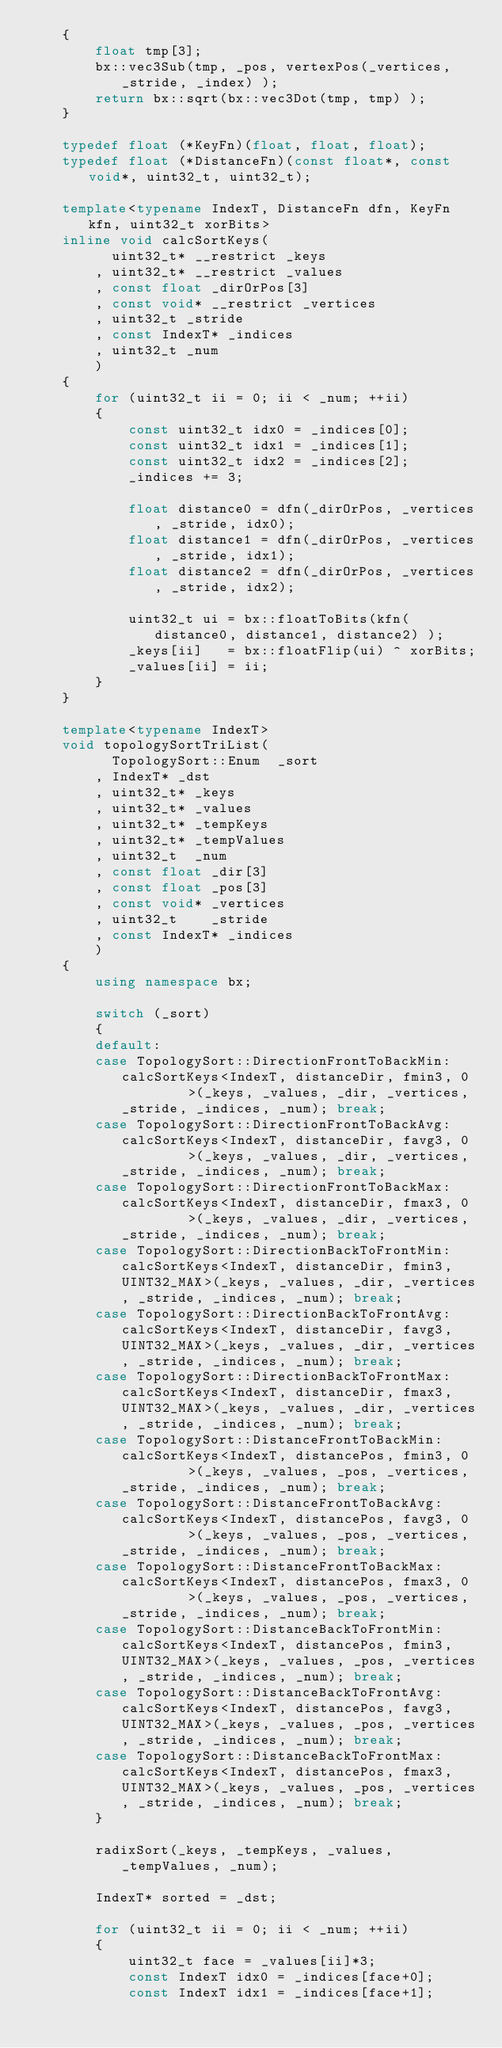<code> <loc_0><loc_0><loc_500><loc_500><_C++_>	{
		float tmp[3];
		bx::vec3Sub(tmp, _pos, vertexPos(_vertices, _stride, _index) );
		return bx::sqrt(bx::vec3Dot(tmp, tmp) );
	}

	typedef float (*KeyFn)(float, float, float);
	typedef float (*DistanceFn)(const float*, const void*, uint32_t, uint32_t);

	template<typename IndexT, DistanceFn dfn, KeyFn kfn, uint32_t xorBits>
	inline void calcSortKeys(
		  uint32_t* __restrict _keys
		, uint32_t* __restrict _values
		, const float _dirOrPos[3]
		, const void* __restrict _vertices
		, uint32_t _stride
		, const IndexT* _indices
		, uint32_t _num
		)
	{
		for (uint32_t ii = 0; ii < _num; ++ii)
		{
			const uint32_t idx0 = _indices[0];
			const uint32_t idx1 = _indices[1];
			const uint32_t idx2 = _indices[2];
			_indices += 3;

			float distance0 = dfn(_dirOrPos, _vertices, _stride, idx0);
			float distance1 = dfn(_dirOrPos, _vertices, _stride, idx1);
			float distance2 = dfn(_dirOrPos, _vertices, _stride, idx2);

			uint32_t ui = bx::floatToBits(kfn(distance0, distance1, distance2) );
			_keys[ii]   = bx::floatFlip(ui) ^ xorBits;
			_values[ii] = ii;
		}
	}

	template<typename IndexT>
	void topologySortTriList(
		  TopologySort::Enum  _sort
		, IndexT* _dst
		, uint32_t* _keys
		, uint32_t* _values
		, uint32_t* _tempKeys
		, uint32_t* _tempValues
		, uint32_t  _num
		, const float _dir[3]
		, const float _pos[3]
		, const void* _vertices
		, uint32_t    _stride
		, const IndexT* _indices
		)
	{
		using namespace bx;

		switch (_sort)
		{
		default:
		case TopologySort::DirectionFrontToBackMin: calcSortKeys<IndexT, distanceDir, fmin3, 0         >(_keys, _values, _dir, _vertices, _stride, _indices, _num); break;
		case TopologySort::DirectionFrontToBackAvg: calcSortKeys<IndexT, distanceDir, favg3, 0         >(_keys, _values, _dir, _vertices, _stride, _indices, _num); break;
		case TopologySort::DirectionFrontToBackMax: calcSortKeys<IndexT, distanceDir, fmax3, 0         >(_keys, _values, _dir, _vertices, _stride, _indices, _num); break;
		case TopologySort::DirectionBackToFrontMin: calcSortKeys<IndexT, distanceDir, fmin3, UINT32_MAX>(_keys, _values, _dir, _vertices, _stride, _indices, _num); break;
		case TopologySort::DirectionBackToFrontAvg: calcSortKeys<IndexT, distanceDir, favg3, UINT32_MAX>(_keys, _values, _dir, _vertices, _stride, _indices, _num); break;
		case TopologySort::DirectionBackToFrontMax: calcSortKeys<IndexT, distanceDir, fmax3, UINT32_MAX>(_keys, _values, _dir, _vertices, _stride, _indices, _num); break;
		case TopologySort::DistanceFrontToBackMin:  calcSortKeys<IndexT, distancePos, fmin3, 0         >(_keys, _values, _pos, _vertices, _stride, _indices, _num); break;
		case TopologySort::DistanceFrontToBackAvg:  calcSortKeys<IndexT, distancePos, favg3, 0         >(_keys, _values, _pos, _vertices, _stride, _indices, _num); break;
		case TopologySort::DistanceFrontToBackMax:  calcSortKeys<IndexT, distancePos, fmax3, 0         >(_keys, _values, _pos, _vertices, _stride, _indices, _num); break;
		case TopologySort::DistanceBackToFrontMin:  calcSortKeys<IndexT, distancePos, fmin3, UINT32_MAX>(_keys, _values, _pos, _vertices, _stride, _indices, _num); break;
		case TopologySort::DistanceBackToFrontAvg:  calcSortKeys<IndexT, distancePos, favg3, UINT32_MAX>(_keys, _values, _pos, _vertices, _stride, _indices, _num); break;
		case TopologySort::DistanceBackToFrontMax:  calcSortKeys<IndexT, distancePos, fmax3, UINT32_MAX>(_keys, _values, _pos, _vertices, _stride, _indices, _num); break;
		}

		radixSort(_keys, _tempKeys, _values, _tempValues, _num);

		IndexT* sorted = _dst;

		for (uint32_t ii = 0; ii < _num; ++ii)
		{
			uint32_t face = _values[ii]*3;
			const IndexT idx0 = _indices[face+0];
			const IndexT idx1 = _indices[face+1];</code> 